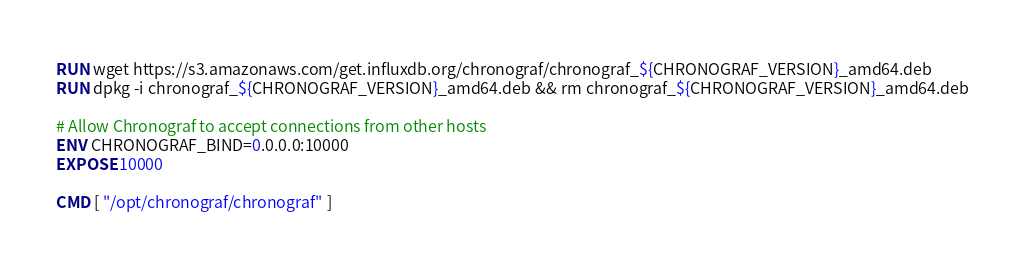<code> <loc_0><loc_0><loc_500><loc_500><_Dockerfile_>RUN wget https://s3.amazonaws.com/get.influxdb.org/chronograf/chronograf_${CHRONOGRAF_VERSION}_amd64.deb
RUN dpkg -i chronograf_${CHRONOGRAF_VERSION}_amd64.deb && rm chronograf_${CHRONOGRAF_VERSION}_amd64.deb

# Allow Chronograf to accept connections from other hosts
ENV CHRONOGRAF_BIND=0.0.0.0:10000
EXPOSE 10000

CMD [ "/opt/chronograf/chronograf" ]
</code> 